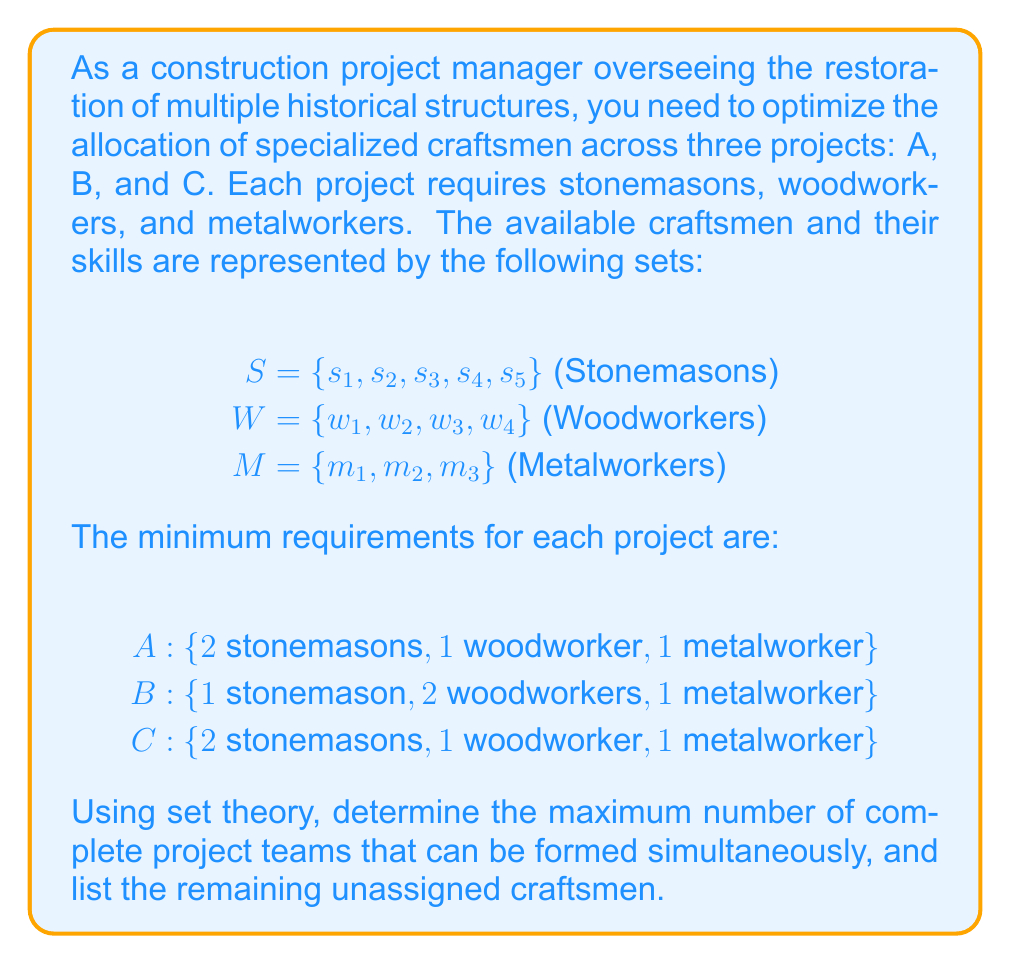Solve this math problem. Let's approach this step-by-step using set theory:

1) First, we need to count the total number of craftsmen in each category:
   $|S| = 5$, $|W| = 4$, $|M| = 3$

2) Now, let's calculate the total requirements for each type of craftsman across all projects:
   Stonemasons: 2 + 1 + 2 = 5
   Woodworkers: 1 + 2 + 1 = 4
   Metalworkers: 1 + 1 + 1 = 3

3) To determine the maximum number of complete project teams, we need to find the limiting factor. We can do this by dividing the available craftsmen by the requirements per project:

   Stonemasons: $\lfloor \frac{5}{5} \rfloor = 1$
   Woodworkers: $\lfloor \frac{4}{4} \rfloor = 1$
   Metalworkers: $\lfloor \frac{3}{3} \rfloor = 1$

   The minimum of these results is 1, so we can form 1 complete set of project teams.

4) After assigning craftsmen to one set of project teams, we can calculate the remaining unassigned craftsmen:

   Stonemasons: $S - (2 + 1 + 2) = 5 - 5 = 0$
   Woodworkers: $W - (1 + 2 + 1) = 4 - 4 = 0$
   Metalworkers: $M - (1 + 1 + 1) = 3 - 3 = 0$

5) Therefore, there are no unassigned craftsmen remaining.
Answer: 1 complete set of project teams; 0 unassigned craftsmen 